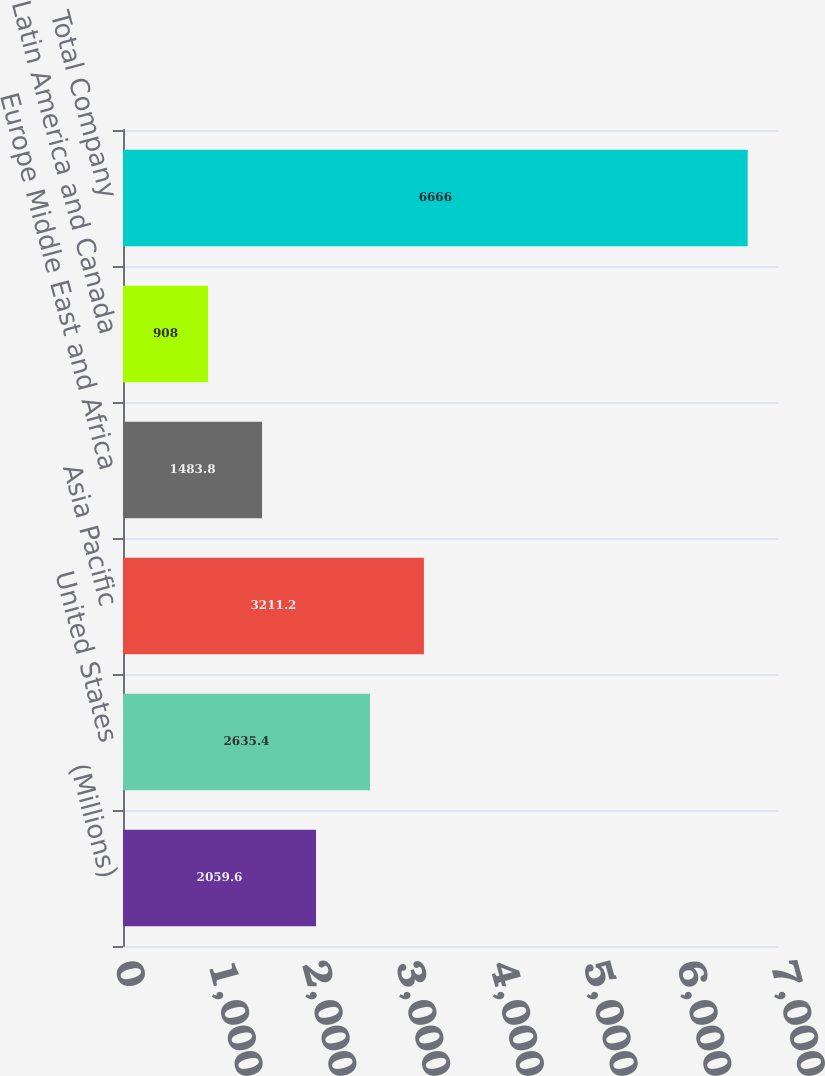Convert chart. <chart><loc_0><loc_0><loc_500><loc_500><bar_chart><fcel>(Millions)<fcel>United States<fcel>Asia Pacific<fcel>Europe Middle East and Africa<fcel>Latin America and Canada<fcel>Total Company<nl><fcel>2059.6<fcel>2635.4<fcel>3211.2<fcel>1483.8<fcel>908<fcel>6666<nl></chart> 